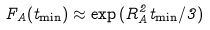Convert formula to latex. <formula><loc_0><loc_0><loc_500><loc_500>F _ { A } ( t _ { \min } ) \approx \exp { ( R ^ { 2 } _ { A } t _ { \min } / 3 ) }</formula> 